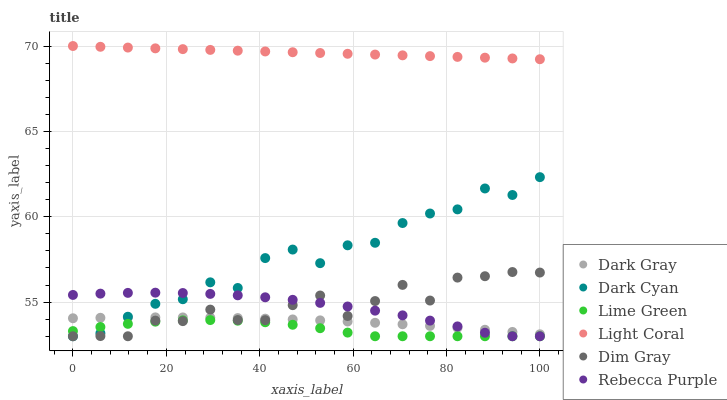Does Lime Green have the minimum area under the curve?
Answer yes or no. Yes. Does Light Coral have the maximum area under the curve?
Answer yes or no. Yes. Does Dim Gray have the minimum area under the curve?
Answer yes or no. No. Does Dim Gray have the maximum area under the curve?
Answer yes or no. No. Is Light Coral the smoothest?
Answer yes or no. Yes. Is Dark Cyan the roughest?
Answer yes or no. Yes. Is Dim Gray the smoothest?
Answer yes or no. No. Is Dim Gray the roughest?
Answer yes or no. No. Does Dim Gray have the lowest value?
Answer yes or no. Yes. Does Dark Gray have the lowest value?
Answer yes or no. No. Does Light Coral have the highest value?
Answer yes or no. Yes. Does Dim Gray have the highest value?
Answer yes or no. No. Is Lime Green less than Light Coral?
Answer yes or no. Yes. Is Dark Gray greater than Lime Green?
Answer yes or no. Yes. Does Dark Cyan intersect Dim Gray?
Answer yes or no. Yes. Is Dark Cyan less than Dim Gray?
Answer yes or no. No. Is Dark Cyan greater than Dim Gray?
Answer yes or no. No. Does Lime Green intersect Light Coral?
Answer yes or no. No. 